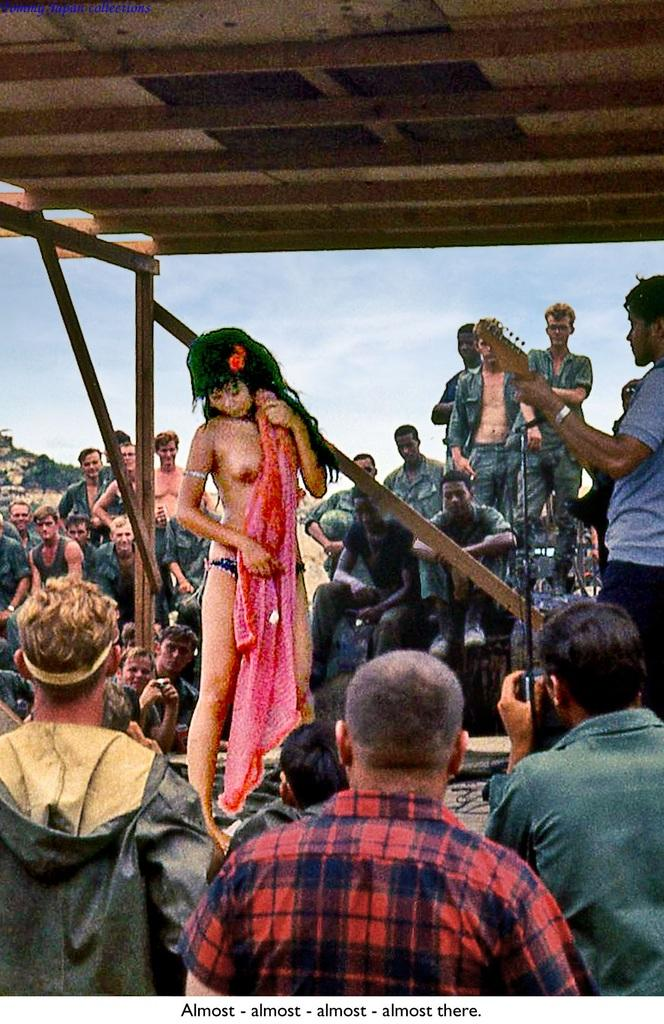What is present in the image that contains both images and text? There is a poster in the image that contains images and text. What type of soda is being advertised on the poster in the image? There is no soda being advertised on the poster in the image, as the facts provided only mention the presence of images and text on the poster. 